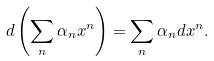Convert formula to latex. <formula><loc_0><loc_0><loc_500><loc_500>d \left ( \sum _ { n } \alpha _ { n } x ^ { n } \right ) = \sum _ { n } \alpha _ { n } d x ^ { n } .</formula> 